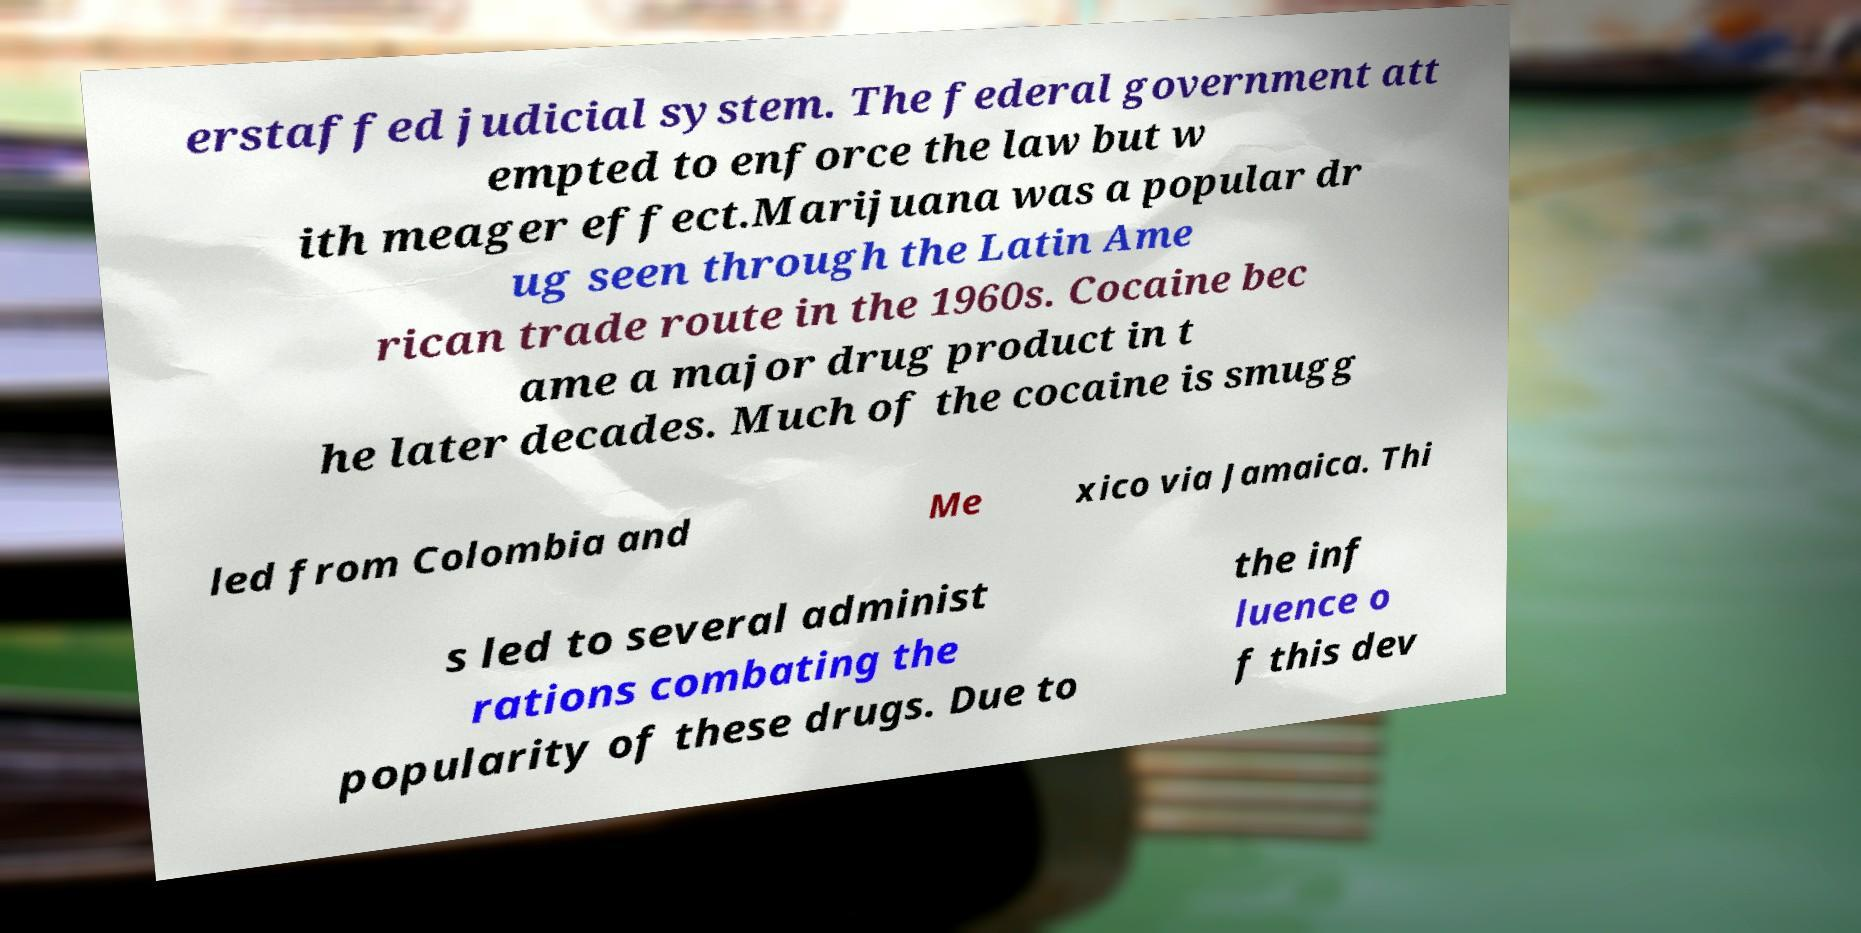For documentation purposes, I need the text within this image transcribed. Could you provide that? erstaffed judicial system. The federal government att empted to enforce the law but w ith meager effect.Marijuana was a popular dr ug seen through the Latin Ame rican trade route in the 1960s. Cocaine bec ame a major drug product in t he later decades. Much of the cocaine is smugg led from Colombia and Me xico via Jamaica. Thi s led to several administ rations combating the popularity of these drugs. Due to the inf luence o f this dev 